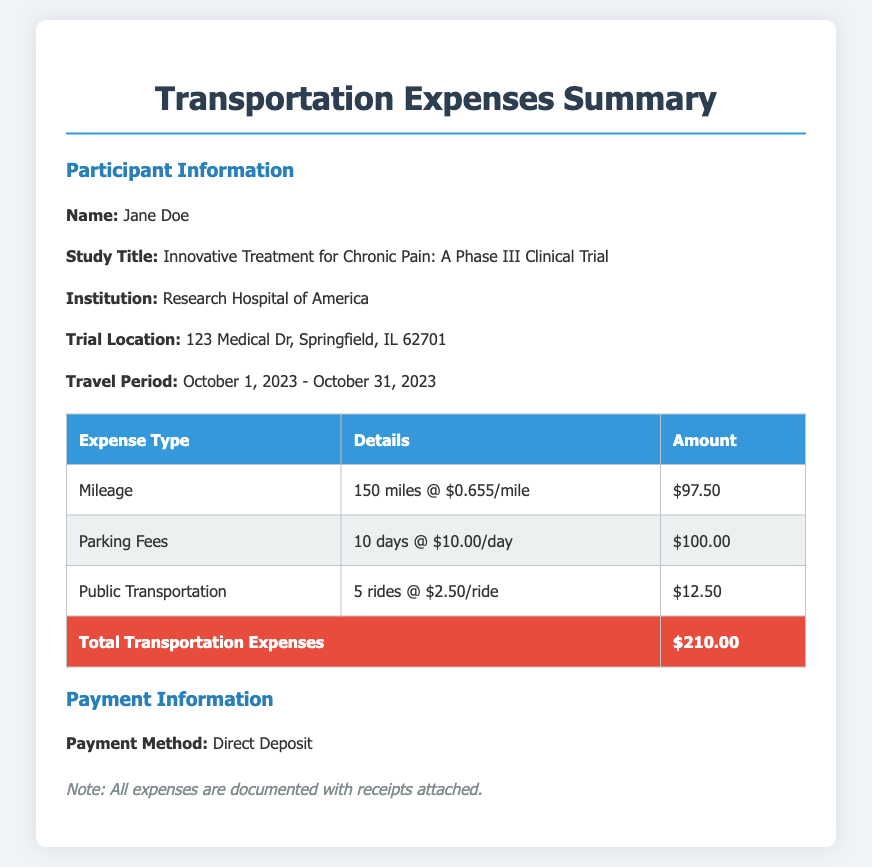What is the participant's name? The participant's name is clearly stated in the document under Participant Information.
Answer: Jane Doe What is the study title? The study title is provided in the document, specifically in the Participant Information section.
Answer: Innovative Treatment for Chronic Pain: A Phase III Clinical Trial What are the total transportation expenses? The total transportation expenses are calculated at the bottom of the expense table, which summarizes all expense types.
Answer: $210.00 How much was spent on parking fees? The amount spent on parking fees is listed in the expense table under Parking Fees.
Answer: $100.00 How many miles were driven for the trip? The mileage amount is specified in the details of the Mileage section in the expense table.
Answer: 150 miles What payment method will be used? The payment method is noted in the Payment Information section towards the end of the document.
Answer: Direct Deposit How many days was parking charged? The number of days for parking fees is mentioned in the Parking Fees details.
Answer: 10 days What is the cost per mile driven? The cost per mile is given in the Mileage section of the expense table, detailing the calculation for mileage expenses.
Answer: $0.655/mile What is the total number of public transportation rides? The document specifies the number of public transportation rides in the details of the Public Transportation expense.
Answer: 5 rides 